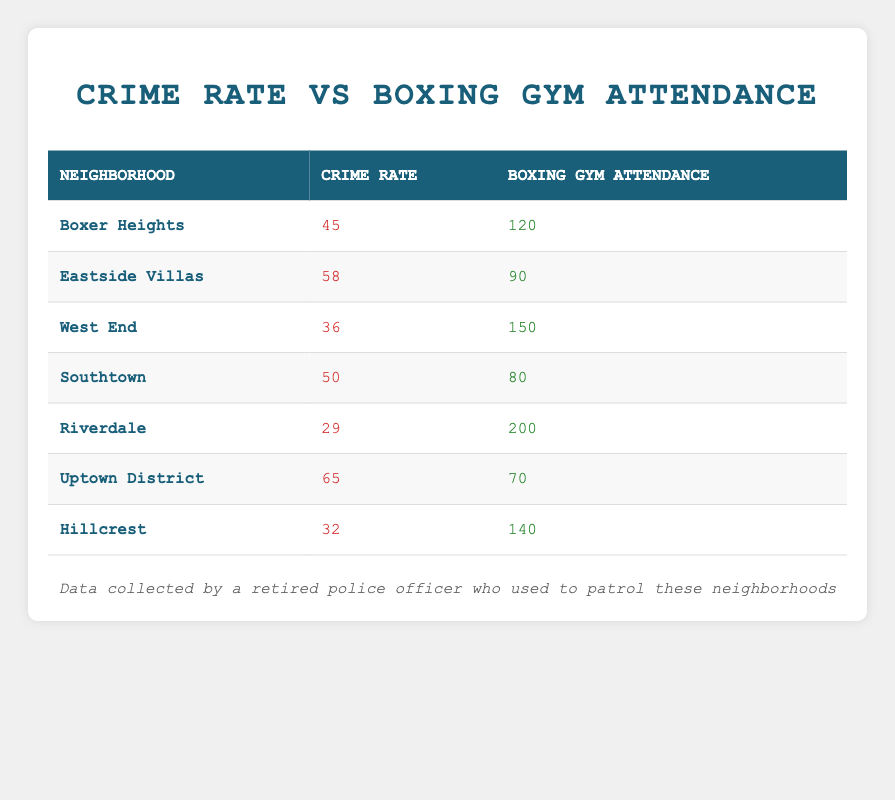What is the crime rate in Riverdale? The table shows the crime rate for each neighborhood. In the row for Riverdale, the crime rate is listed as 29.
Answer: 29 Which neighborhood has the highest boxing gym attendance? To find the neighborhood with the highest attendance, I compare all the values in the "Boxing Gym Attendance" column. Riverdale has the highest value of 200.
Answer: Riverdale Is the crime rate in West End less than the crime rate in Southtown? The crime rate for West End is 36 and for Southtown is 50. Since 36 is less than 50, the statement is true.
Answer: Yes What is the average crime rate across all neighborhoods? To calculate the average, I sum the crime rates: 45 + 58 + 36 + 50 + 29 + 65 + 32 = 315. There are 7 neighborhoods, so the average is 315 divided by 7, which equals approximately 45.
Answer: 45 Which neighborhood has the lowest crime rate, and what is it? By reviewing the crime rates from each neighborhood, I see that Riverdale has the lowest crime rate of 29.
Answer: Riverdale, 29 Is there a correlation where higher boxing gym attendance corresponds to lower crime rates? To assess this, I compare the neighborhoods: Riverdale (200 attendance, 29 crime), West End (150 attendance, 36 crime), and Southtown (80 attendance, 50 crime). It appears that higher attendance is associated with lower crime rates, suggesting a negative correlation.
Answer: Yes What is the total boxing gym attendance for neighborhoods with a crime rate above 50? The neighborhoods with crime rates above 50 are Eastside Villas (90), Uptown District (70), and Southtown (80). Their combined attendance is 90 + 70 + 80 = 240.
Answer: 240 How many neighborhoods have a boxing gym attendance of 100 or more? Looking at the attendance column, the neighborhoods with 100 or more are Boxer Heights (120), West End (150), Riverdale (200), and Hillcrest (140), totaling 4 neighborhoods.
Answer: 4 What is the difference in crime rates between the neighborhood with the highest and the lowest boxing gym attendance? Uptown District has the lowest boxing gym attendance of 70, with a crime rate of 65. Riverdale has the highest attendance of 200, with a crime rate of 29. The difference is 65 - 29 = 36.
Answer: 36 